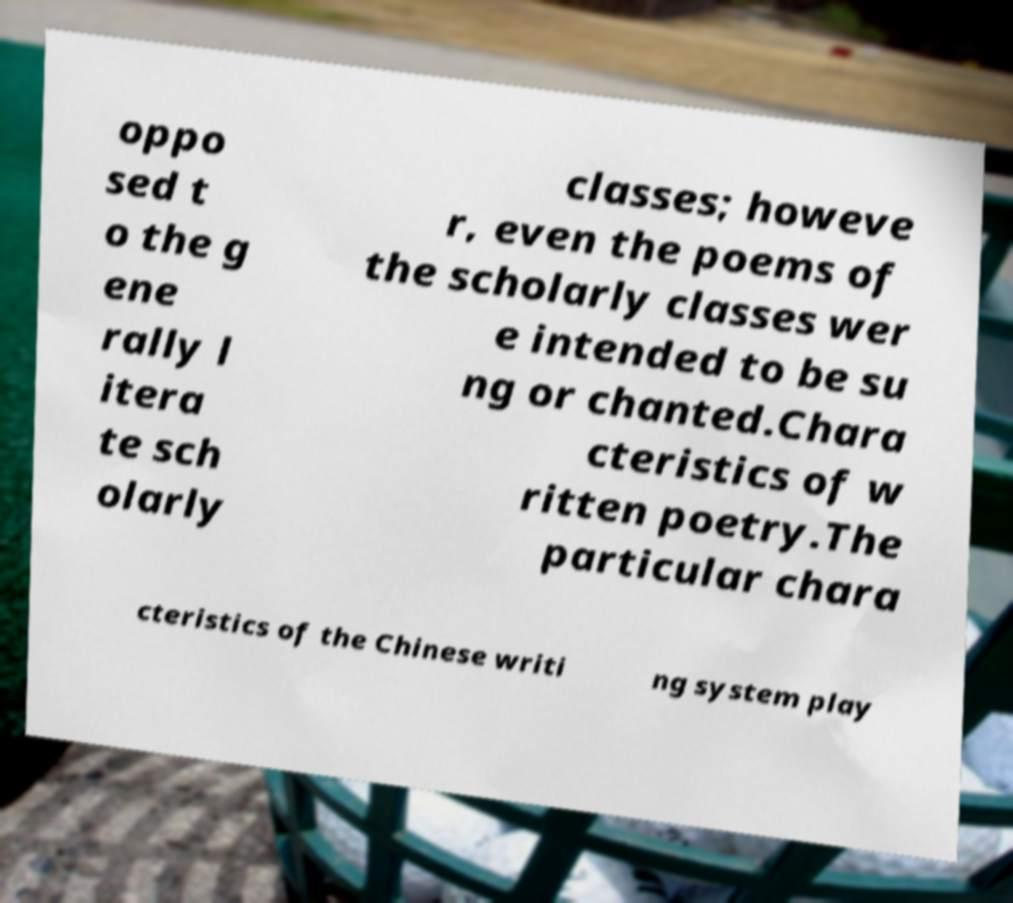What messages or text are displayed in this image? I need them in a readable, typed format. oppo sed t o the g ene rally l itera te sch olarly classes; howeve r, even the poems of the scholarly classes wer e intended to be su ng or chanted.Chara cteristics of w ritten poetry.The particular chara cteristics of the Chinese writi ng system play 